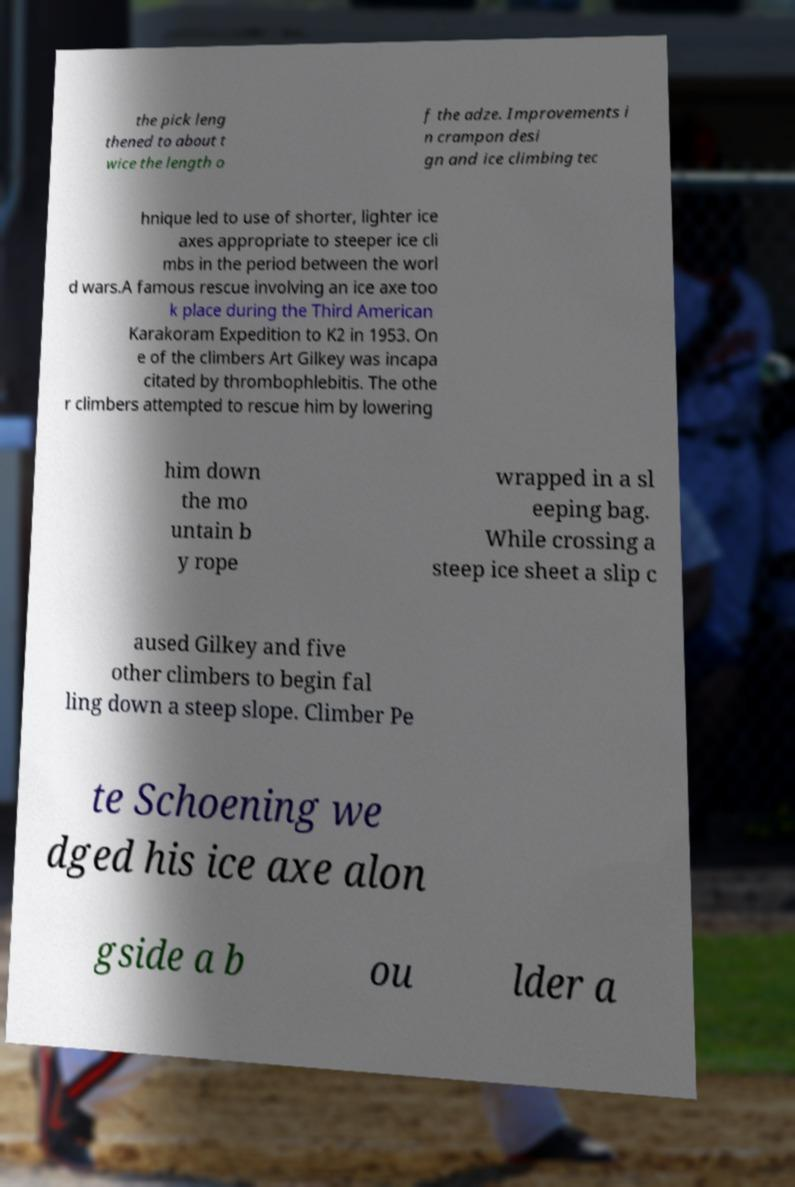Can you accurately transcribe the text from the provided image for me? the pick leng thened to about t wice the length o f the adze. Improvements i n crampon desi gn and ice climbing tec hnique led to use of shorter, lighter ice axes appropriate to steeper ice cli mbs in the period between the worl d wars.A famous rescue involving an ice axe too k place during the Third American Karakoram Expedition to K2 in 1953. On e of the climbers Art Gilkey was incapa citated by thrombophlebitis. The othe r climbers attempted to rescue him by lowering him down the mo untain b y rope wrapped in a sl eeping bag. While crossing a steep ice sheet a slip c aused Gilkey and five other climbers to begin fal ling down a steep slope. Climber Pe te Schoening we dged his ice axe alon gside a b ou lder a 